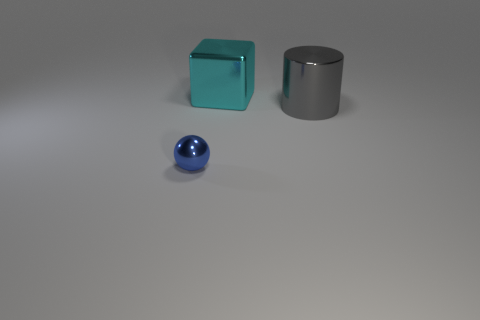There is a large thing that is to the right of the cyan metallic block; are there any gray objects that are on the right side of it?
Keep it short and to the point. No. There is a shiny object on the left side of the large thing that is behind the gray cylinder; what is its shape?
Make the answer very short. Sphere. Is the number of tiny blue metal cubes less than the number of tiny things?
Ensure brevity in your answer.  Yes. Is the small thing made of the same material as the cyan object?
Your answer should be compact. Yes. What color is the shiny thing that is both in front of the cube and to the right of the tiny blue shiny sphere?
Offer a very short reply. Gray. Are there any blocks that have the same size as the blue metallic sphere?
Offer a very short reply. No. What size is the shiny thing in front of the big thing that is in front of the big cyan cube?
Make the answer very short. Small. Are there fewer gray shiny objects that are in front of the tiny blue sphere than shiny cylinders?
Provide a succinct answer. Yes. Does the large cube have the same color as the small thing?
Your answer should be compact. No. The gray metallic thing has what size?
Provide a short and direct response. Large. 